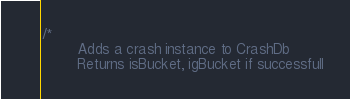<code> <loc_0><loc_0><loc_500><loc_500><_SQL_>/*
        Adds a crash instance to CrashDb
        Returns isBucket, igBucket if successfull</code> 